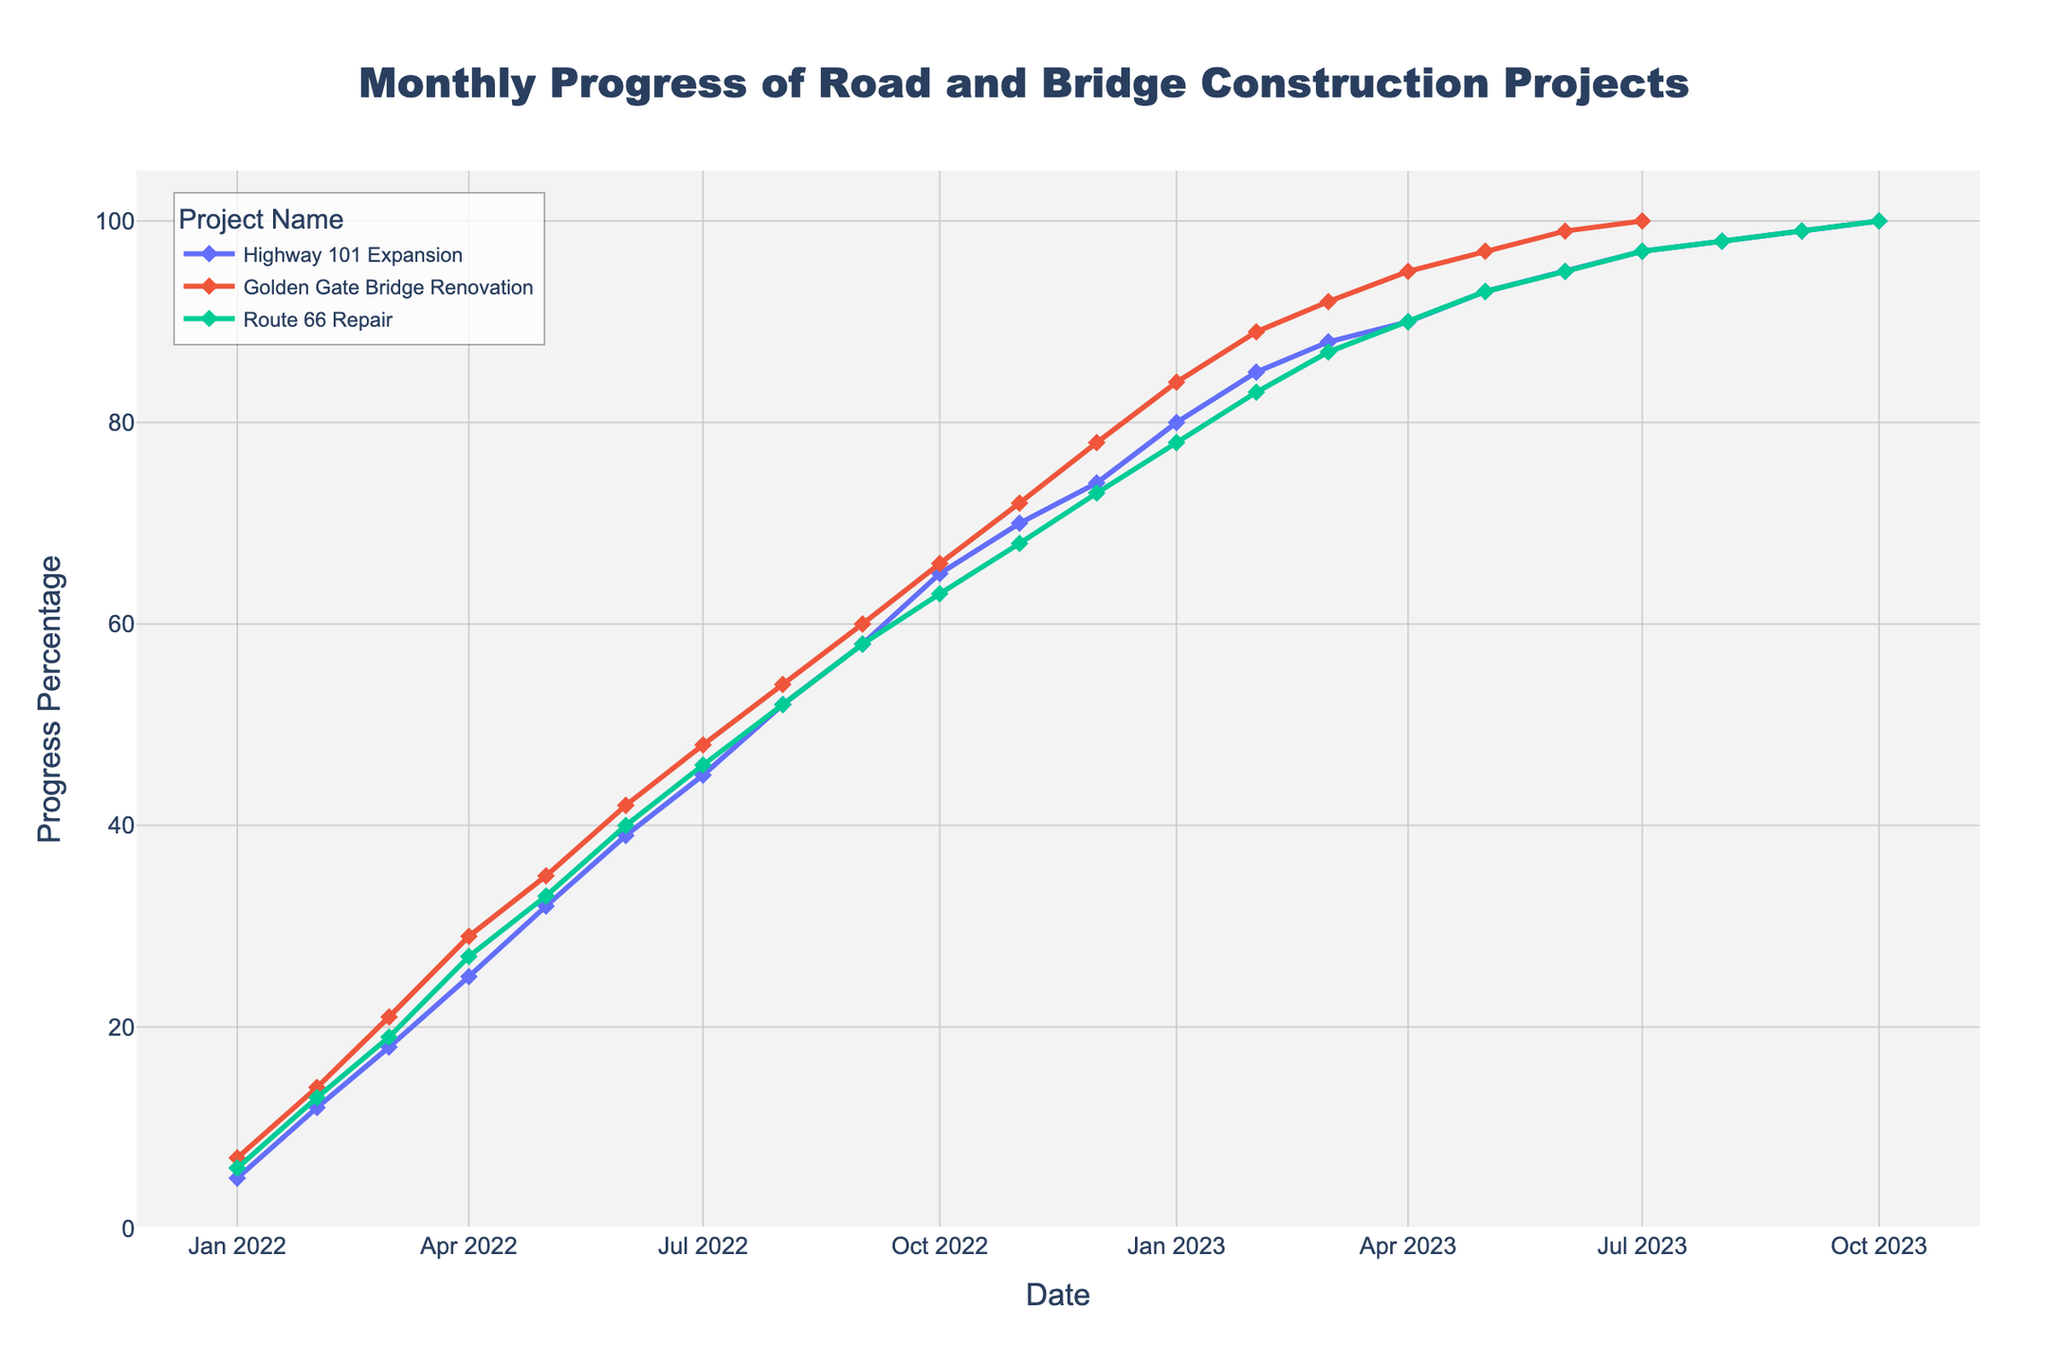When did the "Highway 101 Expansion" project reach 50% progress? Locate the "Highway 101 Expansion" line on the plot and find the month where it crosses the 50% progress mark.
Answer: August 2022 Which project reached 100% progress first? Identify the project lines and check which one first touches the 100% mark along the time axis.
Answer: Golden Gate Bridge Renovation By how much did the "Golden Gate Bridge Renovation" progress from January 2022 to January 2023? Find the progress percentage of "Golden Gate Bridge Renovation" in January 2022 and January 2023 and calculate the difference: 84% - 7% = 77%.
Answer: 77% When did the "Route 66 Repair" project achieve the same progress percentage as "Highway 101 Expansion" in the month of May 2023? Find the progress percentage of "Highway 101 Expansion" in May 2023, which is 93%. Then locate the month where "Route 66 Repair" also has 93%, which is May 2023.
Answer: May 2023 How does the progress of "Route 66 Repair" in June 2022 compare to "Highway 101 Expansion" in the same month? Find the progress percentages for both projects in June 2022. "Route 66 Repair" has 40%, and "Highway 101 Expansion" has 39%. Comparing them, "Route 66 Repair" progress is 1% more.
Answer: 1% more Which project had the highest monthly progress increase from April 2023 to May 2023? Calculate the increase for each project between April and May 2023: "Highway 101 Expansion" is 3% (93% - 90%), "Golden Gate Bridge Renovation" is 2% (97% - 95%), and "Route 66 Repair" is 3% (93% - 90%). "Highway 101 Expansion" and "Route 66 Repair" have the highest at 3%.
Answer: Highway 101 Expansion and Route 66 Repair Which months of 2022 did all three projects show the same progress percentage? Look along the time axis in 2022 and identify where all three lines meet. They all intersect at August 2022.
Answer: August 2022 What is the average progress of "Golden Gate Bridge Renovation" over the last three months on the plot? Find the progress percentages for "Golden Gate Bridge Renovation" in July, August, and September 2023: 100%, 98%, 99%. The average = (100% + 98% + 99%) / 3 = 99%.
Answer: 99% 